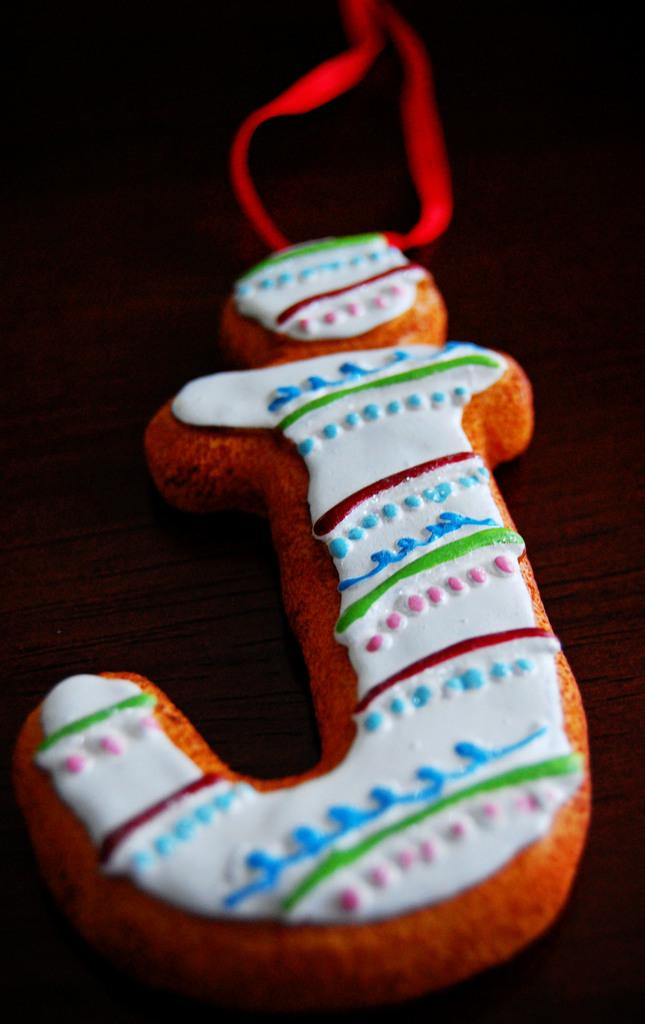What object is featured in the image? There is a keychain in the image. What is written or represented on the keychain? The keychain has the letter 'J' on it. Where is the bun located in the image? There is no bun present in the image. What type of church is depicted in the image? There is no church depicted in the image. 